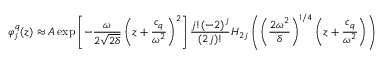<formula> <loc_0><loc_0><loc_500><loc_500>\varphi _ { j } ^ { q } ( z ) \approx A \exp \left [ - \frac { \omega } { 2 \sqrt { 2 \delta } } \left ( z + \frac { c _ { q } } { \omega ^ { 2 } } \right ) ^ { 2 } \right ] \frac { j ! ( - 2 ) ^ { j } } { ( 2 j ) ! } H _ { 2 j } \left ( \left ( \frac { 2 \omega ^ { 2 } } { \delta } \right ) ^ { 1 / 4 } \left ( z + \frac { c _ { q } } { \omega ^ { 2 } } \right ) \right )</formula> 